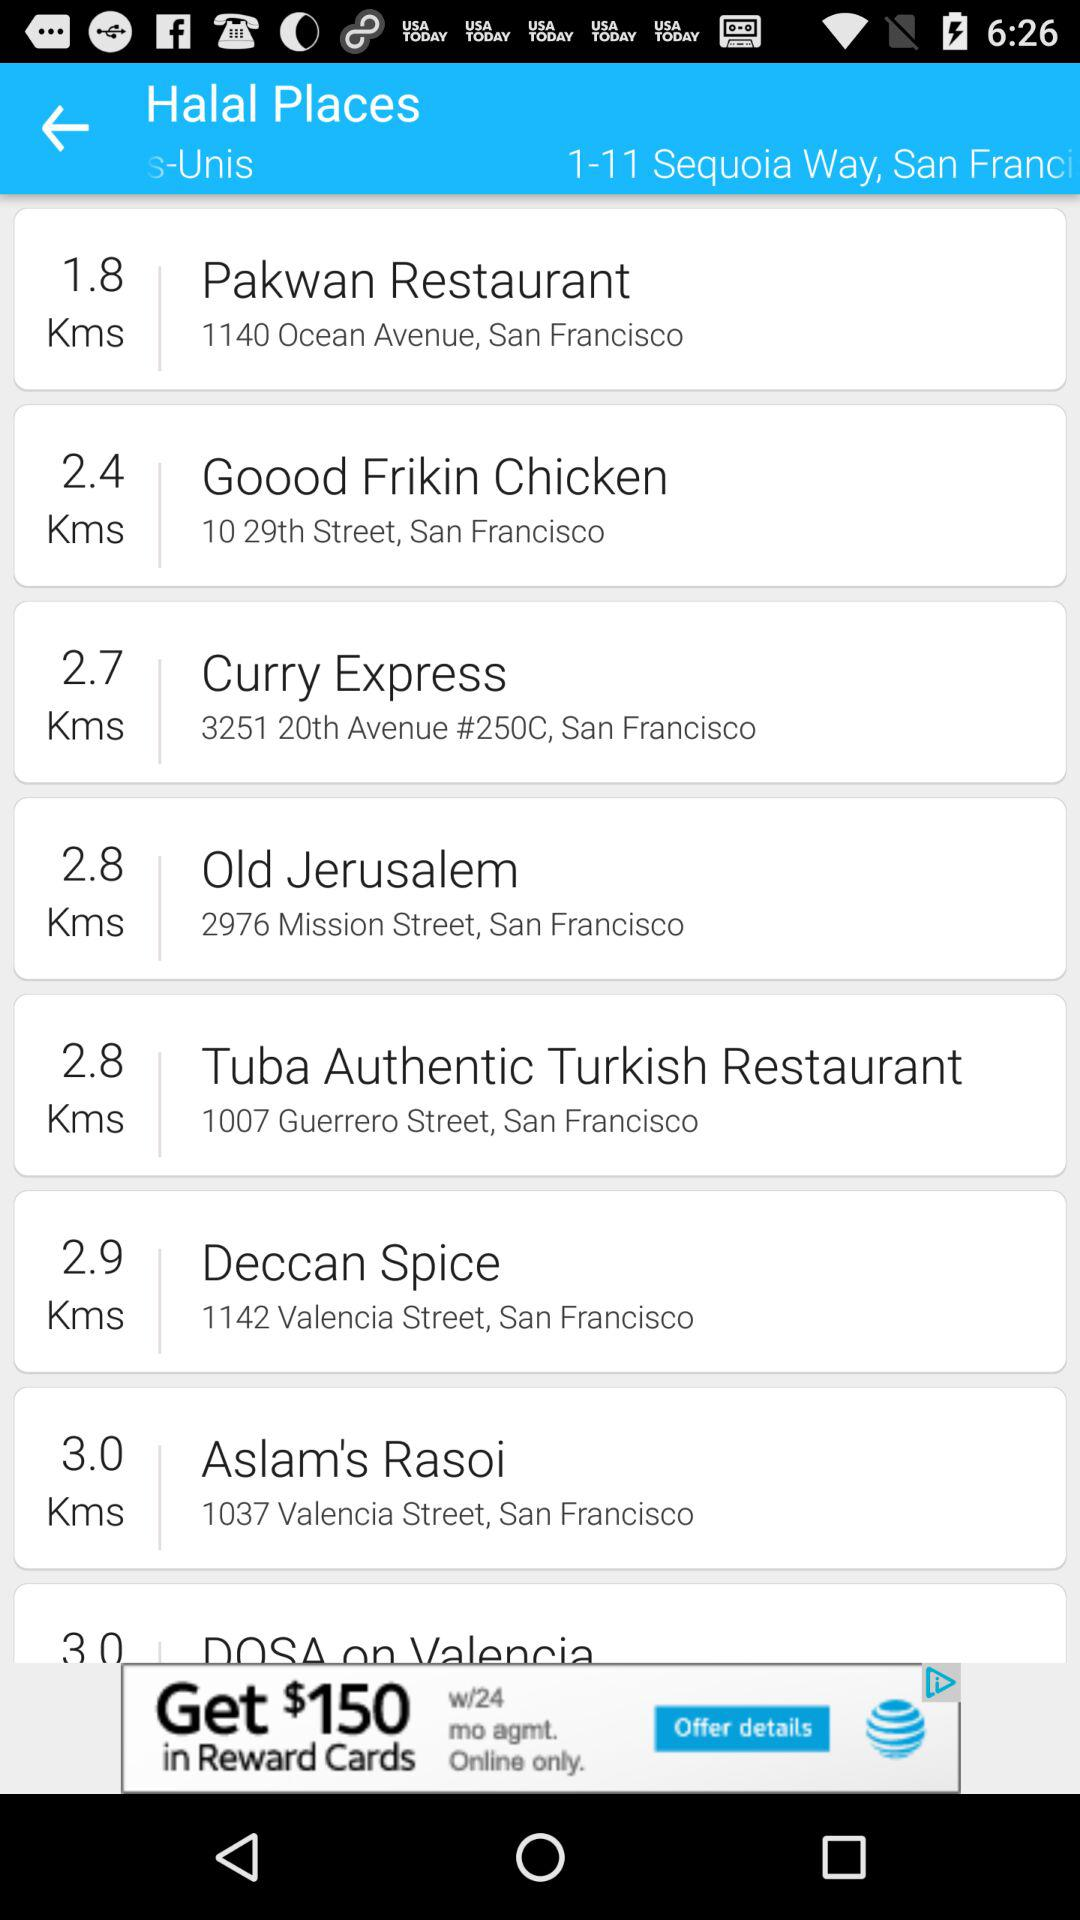What is farthest place from 1-11 sequoia way, San Francisco?
When the provided information is insufficient, respond with <no answer>. <no answer> 